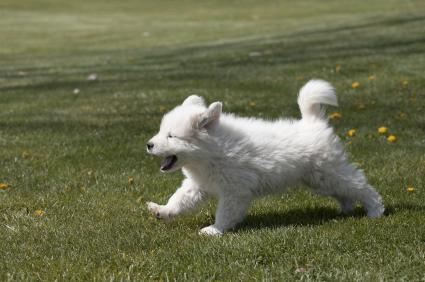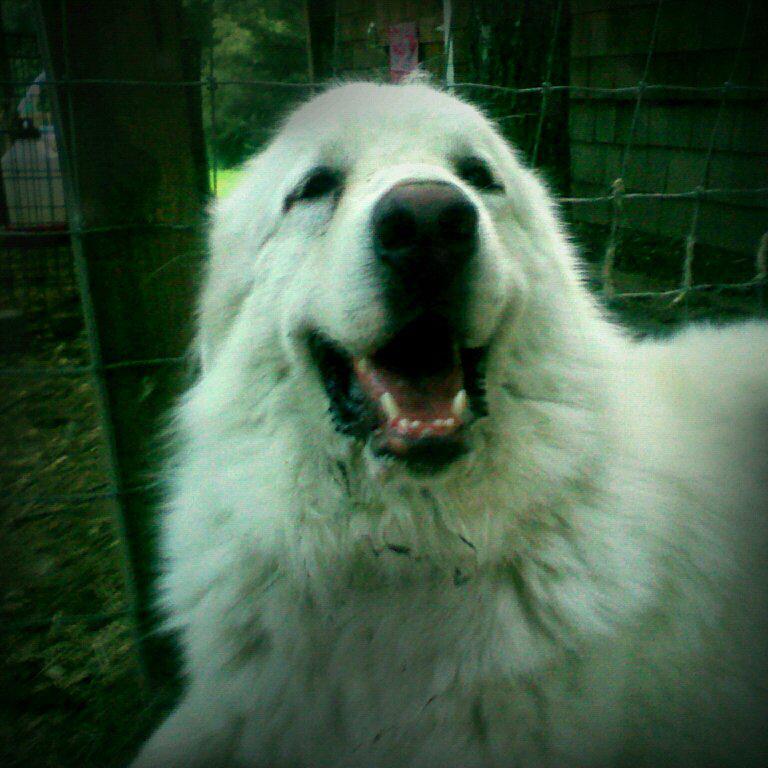The first image is the image on the left, the second image is the image on the right. Evaluate the accuracy of this statement regarding the images: "At least one dog has its mouth open.". Is it true? Answer yes or no. Yes. The first image is the image on the left, the second image is the image on the right. Considering the images on both sides, is "One image includes at least twice as many white dogs as the other image." valid? Answer yes or no. No. 